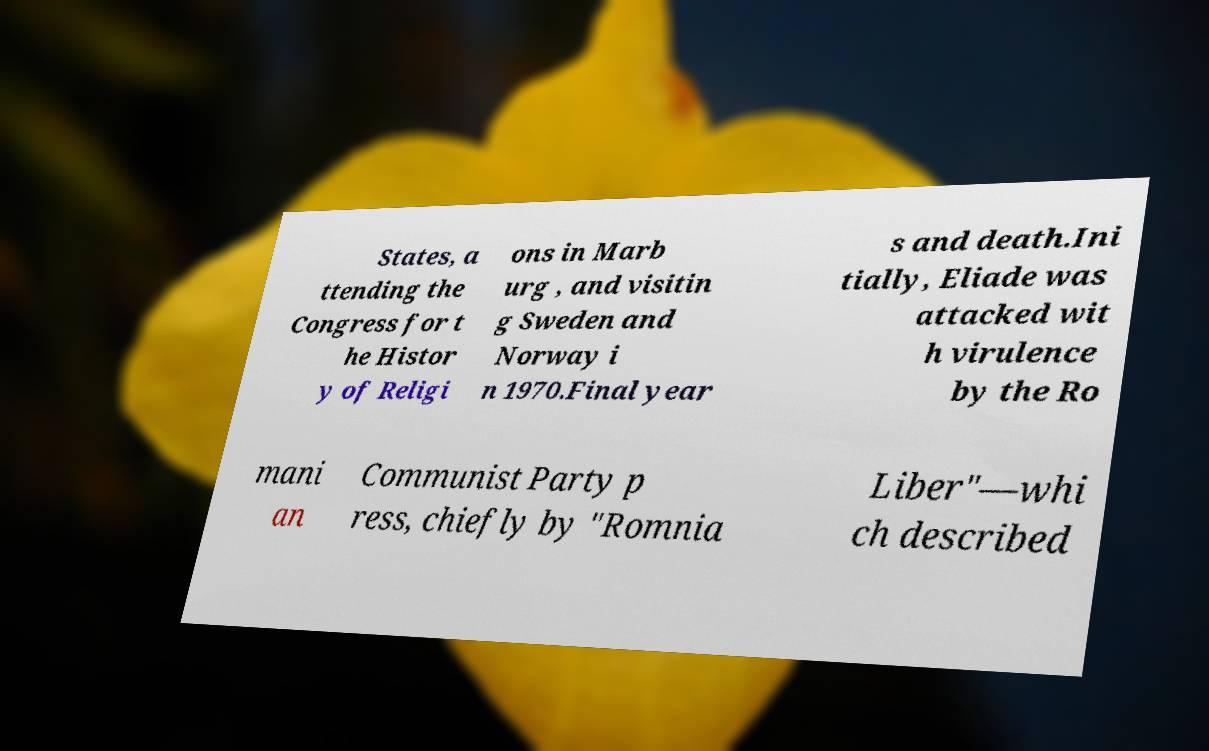Can you accurately transcribe the text from the provided image for me? States, a ttending the Congress for t he Histor y of Religi ons in Marb urg , and visitin g Sweden and Norway i n 1970.Final year s and death.Ini tially, Eliade was attacked wit h virulence by the Ro mani an Communist Party p ress, chiefly by "Romnia Liber"—whi ch described 